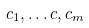<formula> <loc_0><loc_0><loc_500><loc_500>c _ { 1 } , \dots c , c _ { m }</formula> 